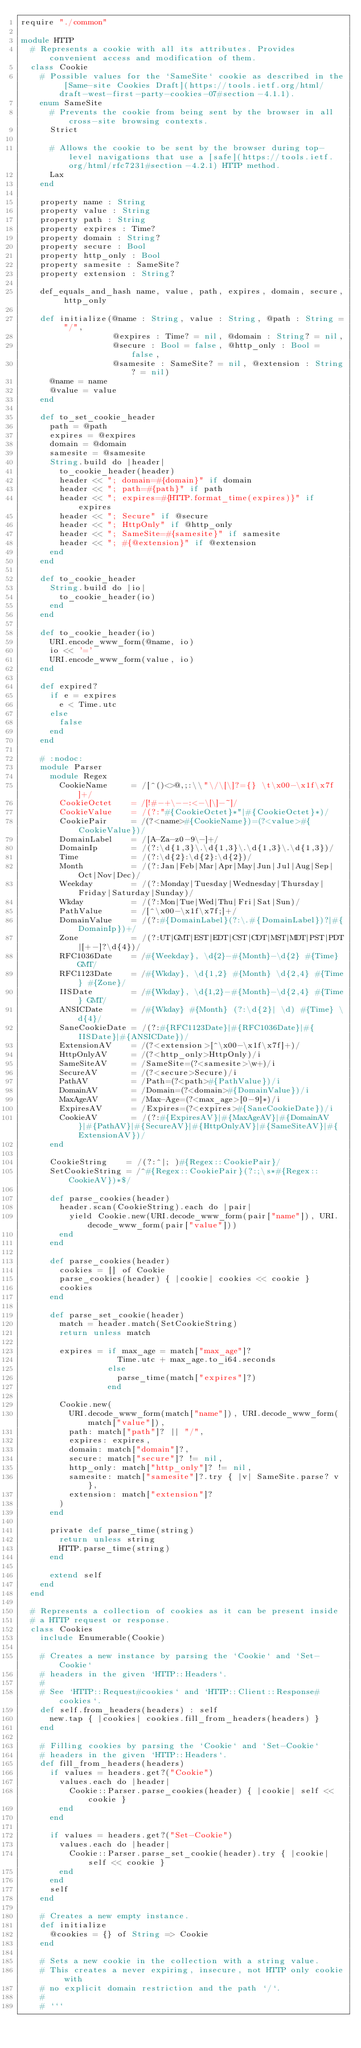Convert code to text. <code><loc_0><loc_0><loc_500><loc_500><_Crystal_>require "./common"

module HTTP
  # Represents a cookie with all its attributes. Provides convenient access and modification of them.
  class Cookie
    # Possible values for the `SameSite` cookie as described in the [Same-site Cookies Draft](https://tools.ietf.org/html/draft-west-first-party-cookies-07#section-4.1.1).
    enum SameSite
      # Prevents the cookie from being sent by the browser in all cross-site browsing contexts.
      Strict

      # Allows the cookie to be sent by the browser during top-level navigations that use a [safe](https://tools.ietf.org/html/rfc7231#section-4.2.1) HTTP method.
      Lax
    end

    property name : String
    property value : String
    property path : String
    property expires : Time?
    property domain : String?
    property secure : Bool
    property http_only : Bool
    property samesite : SameSite?
    property extension : String?

    def_equals_and_hash name, value, path, expires, domain, secure, http_only

    def initialize(@name : String, value : String, @path : String = "/",
                   @expires : Time? = nil, @domain : String? = nil,
                   @secure : Bool = false, @http_only : Bool = false,
                   @samesite : SameSite? = nil, @extension : String? = nil)
      @name = name
      @value = value
    end

    def to_set_cookie_header
      path = @path
      expires = @expires
      domain = @domain
      samesite = @samesite
      String.build do |header|
        to_cookie_header(header)
        header << "; domain=#{domain}" if domain
        header << "; path=#{path}" if path
        header << "; expires=#{HTTP.format_time(expires)}" if expires
        header << "; Secure" if @secure
        header << "; HttpOnly" if @http_only
        header << "; SameSite=#{samesite}" if samesite
        header << "; #{@extension}" if @extension
      end
    end

    def to_cookie_header
      String.build do |io|
        to_cookie_header(io)
      end
    end

    def to_cookie_header(io)
      URI.encode_www_form(@name, io)
      io << '='
      URI.encode_www_form(value, io)
    end

    def expired?
      if e = expires
        e < Time.utc
      else
        false
      end
    end

    # :nodoc:
    module Parser
      module Regex
        CookieName     = /[^()<>@,;:\\"\/\[\]?={} \t\x00-\x1f\x7f]+/
        CookieOctet    = /[!#-+\--:<-\[\]-~]/
        CookieValue    = /(?:"#{CookieOctet}*"|#{CookieOctet}*)/
        CookiePair     = /(?<name>#{CookieName})=(?<value>#{CookieValue})/
        DomainLabel    = /[A-Za-z0-9\-]+/
        DomainIp       = /(?:\d{1,3}\.\d{1,3}\.\d{1,3}\.\d{1,3})/
        Time           = /(?:\d{2}:\d{2}:\d{2})/
        Month          = /(?:Jan|Feb|Mar|Apr|May|Jun|Jul|Aug|Sep|Oct|Nov|Dec)/
        Weekday        = /(?:Monday|Tuesday|Wednesday|Thursday|Friday|Saturday|Sunday)/
        Wkday          = /(?:Mon|Tue|Wed|Thu|Fri|Sat|Sun)/
        PathValue      = /[^\x00-\x1f\x7f;]+/
        DomainValue    = /(?:#{DomainLabel}(?:\.#{DomainLabel})?|#{DomainIp})+/
        Zone           = /(?:UT|GMT|EST|EDT|CST|CDT|MST|MDT|PST|PDT|[+-]?\d{4})/
        RFC1036Date    = /#{Weekday}, \d{2}-#{Month}-\d{2} #{Time} GMT/
        RFC1123Date    = /#{Wkday}, \d{1,2} #{Month} \d{2,4} #{Time} #{Zone}/
        IISDate        = /#{Wkday}, \d{1,2}-#{Month}-\d{2,4} #{Time} GMT/
        ANSICDate      = /#{Wkday} #{Month} (?:\d{2}| \d) #{Time} \d{4}/
        SaneCookieDate = /(?:#{RFC1123Date}|#{RFC1036Date}|#{IISDate}|#{ANSICDate})/
        ExtensionAV    = /(?<extension>[^\x00-\x1f\x7f]+)/
        HttpOnlyAV     = /(?<http_only>HttpOnly)/i
        SameSiteAV     = /SameSite=(?<samesite>\w+)/i
        SecureAV       = /(?<secure>Secure)/i
        PathAV         = /Path=(?<path>#{PathValue})/i
        DomainAV       = /Domain=(?<domain>#{DomainValue})/i
        MaxAgeAV       = /Max-Age=(?<max_age>[0-9]*)/i
        ExpiresAV      = /Expires=(?<expires>#{SaneCookieDate})/i
        CookieAV       = /(?:#{ExpiresAV}|#{MaxAgeAV}|#{DomainAV}|#{PathAV}|#{SecureAV}|#{HttpOnlyAV}|#{SameSiteAV}|#{ExtensionAV})/
      end

      CookieString    = /(?:^|; )#{Regex::CookiePair}/
      SetCookieString = /^#{Regex::CookiePair}(?:;\s*#{Regex::CookieAV})*$/

      def parse_cookies(header)
        header.scan(CookieString).each do |pair|
          yield Cookie.new(URI.decode_www_form(pair["name"]), URI.decode_www_form(pair["value"]))
        end
      end

      def parse_cookies(header)
        cookies = [] of Cookie
        parse_cookies(header) { |cookie| cookies << cookie }
        cookies
      end

      def parse_set_cookie(header)
        match = header.match(SetCookieString)
        return unless match

        expires = if max_age = match["max_age"]?
                    Time.utc + max_age.to_i64.seconds
                  else
                    parse_time(match["expires"]?)
                  end

        Cookie.new(
          URI.decode_www_form(match["name"]), URI.decode_www_form(match["value"]),
          path: match["path"]? || "/",
          expires: expires,
          domain: match["domain"]?,
          secure: match["secure"]? != nil,
          http_only: match["http_only"]? != nil,
          samesite: match["samesite"]?.try { |v| SameSite.parse? v },
          extension: match["extension"]?
        )
      end

      private def parse_time(string)
        return unless string
        HTTP.parse_time(string)
      end

      extend self
    end
  end

  # Represents a collection of cookies as it can be present inside
  # a HTTP request or response.
  class Cookies
    include Enumerable(Cookie)

    # Creates a new instance by parsing the `Cookie` and `Set-Cookie`
    # headers in the given `HTTP::Headers`.
    #
    # See `HTTP::Request#cookies` and `HTTP::Client::Response#cookies`.
    def self.from_headers(headers) : self
      new.tap { |cookies| cookies.fill_from_headers(headers) }
    end

    # Filling cookies by parsing the `Cookie` and `Set-Cookie`
    # headers in the given `HTTP::Headers`.
    def fill_from_headers(headers)
      if values = headers.get?("Cookie")
        values.each do |header|
          Cookie::Parser.parse_cookies(header) { |cookie| self << cookie }
        end
      end

      if values = headers.get?("Set-Cookie")
        values.each do |header|
          Cookie::Parser.parse_set_cookie(header).try { |cookie| self << cookie }
        end
      end
      self
    end

    # Creates a new empty instance.
    def initialize
      @cookies = {} of String => Cookie
    end

    # Sets a new cookie in the collection with a string value.
    # This creates a never expiring, insecure, not HTTP only cookie with
    # no explicit domain restriction and the path `/`.
    #
    # ```</code> 